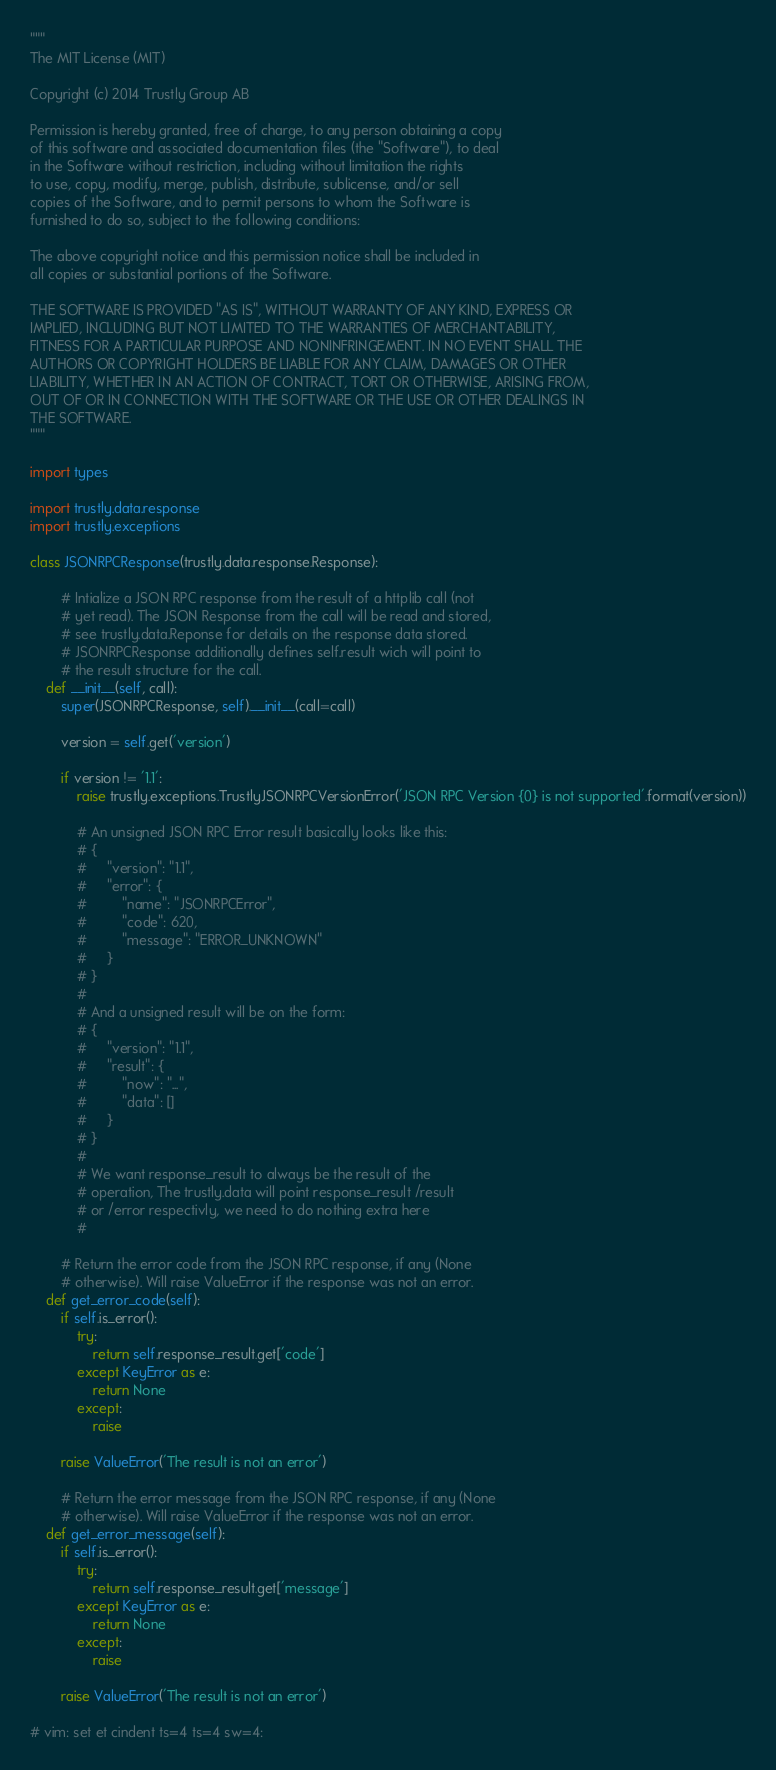Convert code to text. <code><loc_0><loc_0><loc_500><loc_500><_Python_>"""
The MIT License (MIT)

Copyright (c) 2014 Trustly Group AB

Permission is hereby granted, free of charge, to any person obtaining a copy
of this software and associated documentation files (the "Software"), to deal
in the Software without restriction, including without limitation the rights
to use, copy, modify, merge, publish, distribute, sublicense, and/or sell
copies of the Software, and to permit persons to whom the Software is
furnished to do so, subject to the following conditions:

The above copyright notice and this permission notice shall be included in
all copies or substantial portions of the Software.

THE SOFTWARE IS PROVIDED "AS IS", WITHOUT WARRANTY OF ANY KIND, EXPRESS OR
IMPLIED, INCLUDING BUT NOT LIMITED TO THE WARRANTIES OF MERCHANTABILITY,
FITNESS FOR A PARTICULAR PURPOSE AND NONINFRINGEMENT. IN NO EVENT SHALL THE
AUTHORS OR COPYRIGHT HOLDERS BE LIABLE FOR ANY CLAIM, DAMAGES OR OTHER
LIABILITY, WHETHER IN AN ACTION OF CONTRACT, TORT OR OTHERWISE, ARISING FROM,
OUT OF OR IN CONNECTION WITH THE SOFTWARE OR THE USE OR OTHER DEALINGS IN
THE SOFTWARE.
"""

import types

import trustly.data.response
import trustly.exceptions

class JSONRPCResponse(trustly.data.response.Response):

        # Intialize a JSON RPC response from the result of a httplib call (not
        # yet read). The JSON Response from the call will be read and stored,
        # see trustly.data.Reponse for details on the response data stored. 
        # JSONRPCResponse additionally defines self.result wich will point to
        # the result structure for the call. 
    def __init__(self, call):
        super(JSONRPCResponse, self).__init__(call=call)

        version = self.get('version')

        if version != '1.1':
            raise trustly.exceptions.TrustlyJSONRPCVersionError('JSON RPC Version {0} is not supported'.format(version))

			# An unsigned JSON RPC Error result basically looks like this:
			# {
			#     "version": "1.1",
			#     "error": {
			#         "name": "JSONRPCError",
			#         "code": 620,
			#         "message": "ERROR_UNKNOWN"
			#     }
			# }
			#
			# And a unsigned result will be on the form:
			# {
			#     "version": "1.1",
			#     "result": {
			#         "now": "...",
			#         "data": []
			#     }
			# }
			#
			# We want response_result to always be the result of the
			# operation, The trustly.data will point response_result /result
			# or /error respectivly, we need to do nothing extra here
			#

        # Return the error code from the JSON RPC response, if any (None
        # otherwise). Will raise ValueError if the response was not an error.
    def get_error_code(self):
        if self.is_error():
            try:
                return self.response_result.get['code']
            except KeyError as e:
                return None
            except:
                raise

        raise ValueError('The result is not an error')

        # Return the error message from the JSON RPC response, if any (None
        # otherwise). Will raise ValueError if the response was not an error.
    def get_error_message(self):
        if self.is_error():
            try:
                return self.response_result.get['message']
            except KeyError as e:
                return None
            except:
                raise

        raise ValueError('The result is not an error')

# vim: set et cindent ts=4 ts=4 sw=4:
</code> 